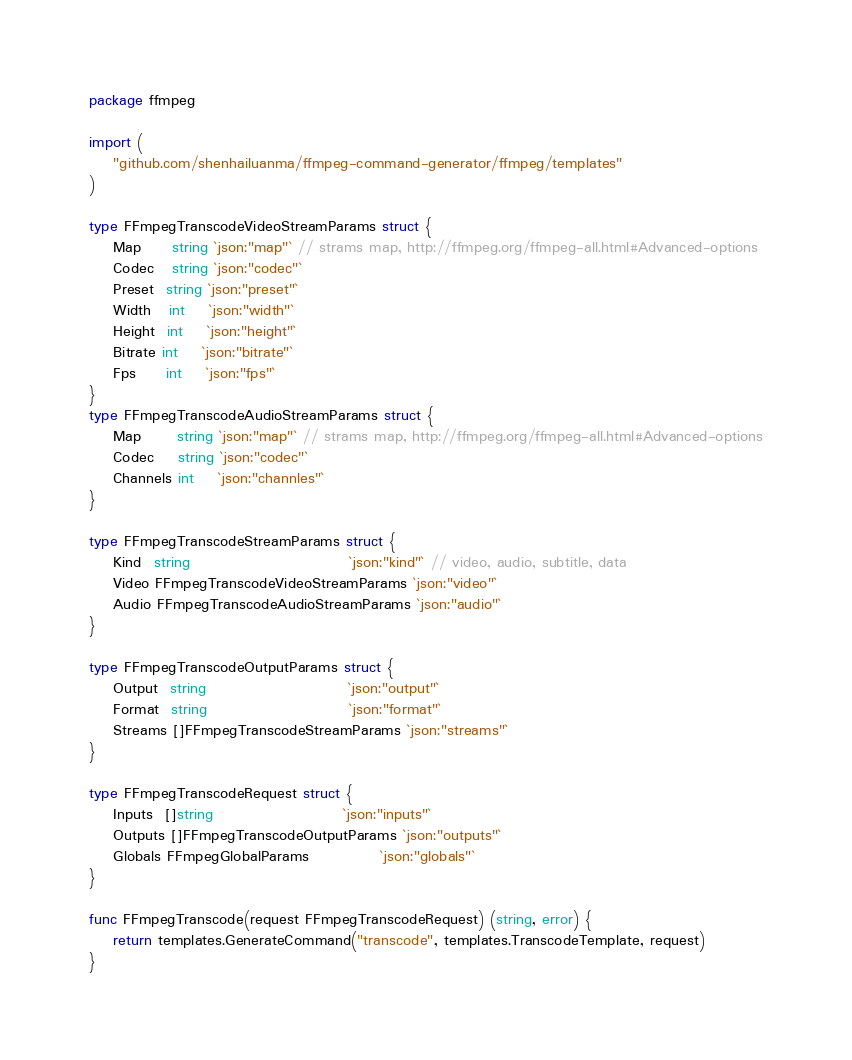Convert code to text. <code><loc_0><loc_0><loc_500><loc_500><_Go_>package ffmpeg

import (
	"github.com/shenhailuanma/ffmpeg-command-generator/ffmpeg/templates"
)

type FFmpegTranscodeVideoStreamParams struct {
	Map     string `json:"map"` // strams map, http://ffmpeg.org/ffmpeg-all.html#Advanced-options
	Codec   string `json:"codec"`
	Preset  string `json:"preset"`
	Width   int    `json:"width"`
	Height  int    `json:"height"`
	Bitrate int    `json:"bitrate"`
	Fps     int    `json:"fps"`
}
type FFmpegTranscodeAudioStreamParams struct {
	Map      string `json:"map"` // strams map, http://ffmpeg.org/ffmpeg-all.html#Advanced-options
	Codec    string `json:"codec"`
	Channels int    `json:"channles"`
}

type FFmpegTranscodeStreamParams struct {
	Kind  string                           `json:"kind"` // video, audio, subtitle, data
	Video FFmpegTranscodeVideoStreamParams `json:"video"`
	Audio FFmpegTranscodeAudioStreamParams `json:"audio"`
}

type FFmpegTranscodeOutputParams struct {
	Output  string                        `json:"output"`
	Format  string                        `json:"format"`
	Streams []FFmpegTranscodeStreamParams `json:"streams"`
}

type FFmpegTranscodeRequest struct {
	Inputs  []string                      `json:"inputs"`
	Outputs []FFmpegTranscodeOutputParams `json:"outputs"`
	Globals FFmpegGlobalParams            `json:"globals"`
}

func FFmpegTranscode(request FFmpegTranscodeRequest) (string, error) {
	return templates.GenerateCommand("transcode", templates.TranscodeTemplate, request)
}
</code> 